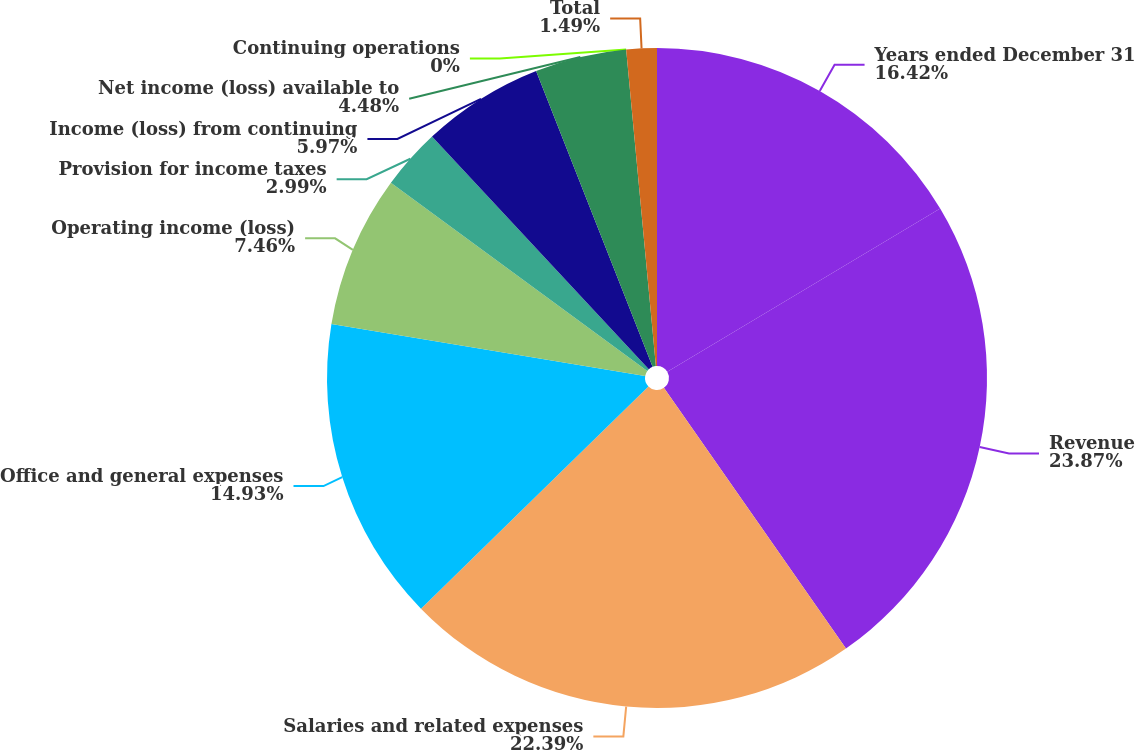Convert chart. <chart><loc_0><loc_0><loc_500><loc_500><pie_chart><fcel>Years ended December 31<fcel>Revenue<fcel>Salaries and related expenses<fcel>Office and general expenses<fcel>Operating income (loss)<fcel>Provision for income taxes<fcel>Income (loss) from continuing<fcel>Net income (loss) available to<fcel>Continuing operations<fcel>Total<nl><fcel>16.42%<fcel>23.88%<fcel>22.39%<fcel>14.93%<fcel>7.46%<fcel>2.99%<fcel>5.97%<fcel>4.48%<fcel>0.0%<fcel>1.49%<nl></chart> 